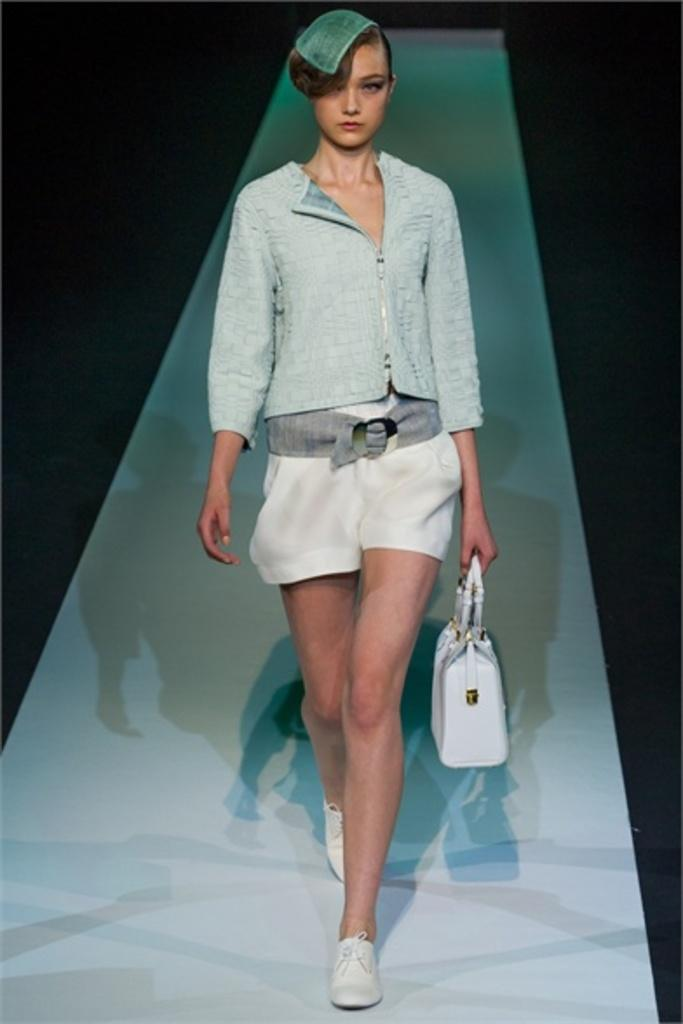Who is the main subject in the image? There is a woman in the image. What is the woman doing in the image? The woman is walking on the floor. What is the woman holding in the image? The woman is holding a bag with her hand. What type of ant can be seen crawling on the woman's shoulder in the image? There is no ant present on the woman's shoulder in the image. Can you tell me what the woman bought, based on the receipt in her hand? The woman is not holding a receipt in her hand in the image. 